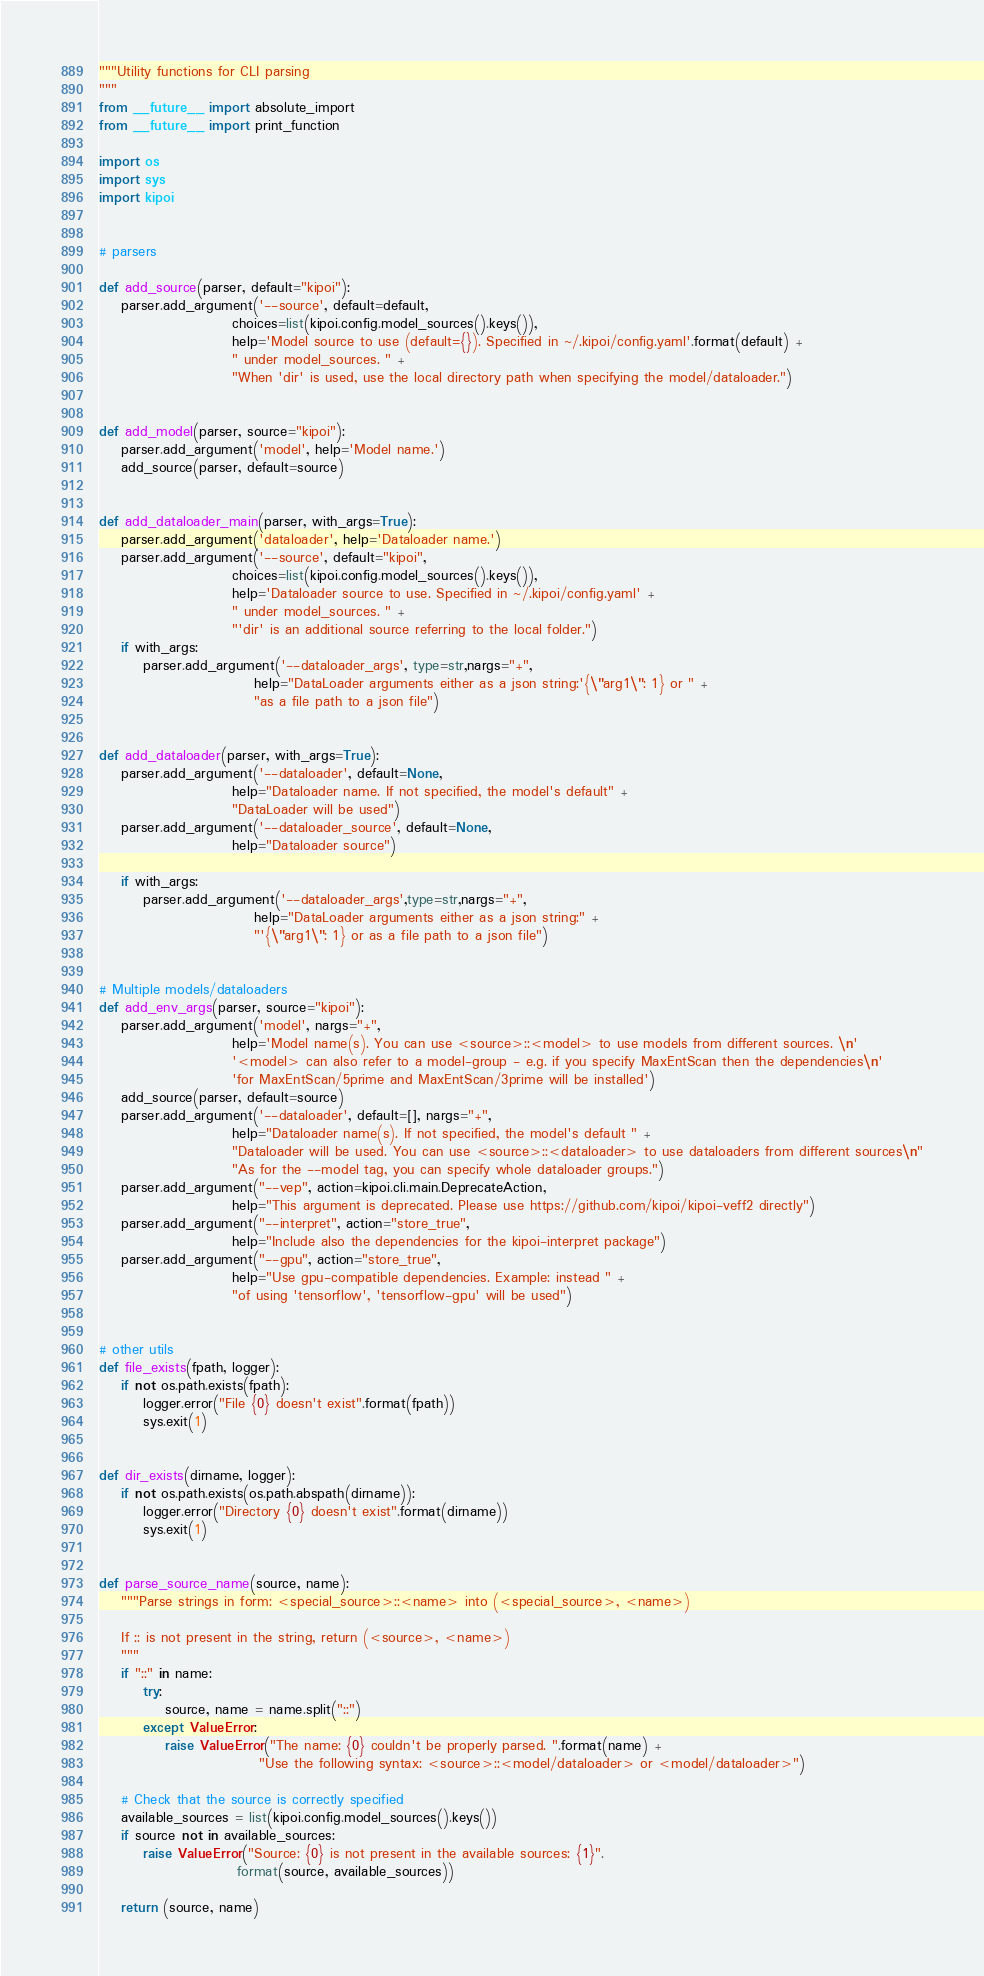<code> <loc_0><loc_0><loc_500><loc_500><_Python_>"""Utility functions for CLI parsing
"""
from __future__ import absolute_import
from __future__ import print_function

import os
import sys
import kipoi


# parsers

def add_source(parser, default="kipoi"):
    parser.add_argument('--source', default=default,
                        choices=list(kipoi.config.model_sources().keys()),
                        help='Model source to use (default={}). Specified in ~/.kipoi/config.yaml'.format(default) +
                        " under model_sources. " +
                        "When 'dir' is used, use the local directory path when specifying the model/dataloader.")


def add_model(parser, source="kipoi"):
    parser.add_argument('model', help='Model name.')
    add_source(parser, default=source)


def add_dataloader_main(parser, with_args=True):
    parser.add_argument('dataloader', help='Dataloader name.')
    parser.add_argument('--source', default="kipoi",
                        choices=list(kipoi.config.model_sources().keys()),
                        help='Dataloader source to use. Specified in ~/.kipoi/config.yaml' +
                        " under model_sources. " +
                        "'dir' is an additional source referring to the local folder.")
    if with_args:
        parser.add_argument('--dataloader_args', type=str,nargs="+",
                            help="DataLoader arguments either as a json string:'{\"arg1\": 1} or " +
                            "as a file path to a json file")


def add_dataloader(parser, with_args=True):
    parser.add_argument('--dataloader', default=None,
                        help="Dataloader name. If not specified, the model's default" +
                        "DataLoader will be used")
    parser.add_argument('--dataloader_source', default=None,
                        help="Dataloader source")

    if with_args:
        parser.add_argument('--dataloader_args',type=str,nargs="+",
                            help="DataLoader arguments either as a json string:" +
                            "'{\"arg1\": 1} or as a file path to a json file")


# Multiple models/dataloaders
def add_env_args(parser, source="kipoi"):
    parser.add_argument('model', nargs="+",
                        help='Model name(s). You can use <source>::<model> to use models from different sources. \n'
                        '<model> can also refer to a model-group - e.g. if you specify MaxEntScan then the dependencies\n'
                        'for MaxEntScan/5prime and MaxEntScan/3prime will be installed')
    add_source(parser, default=source)
    parser.add_argument('--dataloader', default=[], nargs="+",
                        help="Dataloader name(s). If not specified, the model's default " +
                        "Dataloader will be used. You can use <source>::<dataloader> to use dataloaders from different sources\n"
                        "As for the --model tag, you can specify whole dataloader groups.")
    parser.add_argument("--vep", action=kipoi.cli.main.DeprecateAction,
                        help="This argument is deprecated. Please use https://github.com/kipoi/kipoi-veff2 directly")
    parser.add_argument("--interpret", action="store_true",
                        help="Include also the dependencies for the kipoi-interpret package")
    parser.add_argument("--gpu", action="store_true",
                        help="Use gpu-compatible dependencies. Example: instead " +
                        "of using 'tensorflow', 'tensorflow-gpu' will be used")


# other utils
def file_exists(fpath, logger):
    if not os.path.exists(fpath):
        logger.error("File {0} doesn't exist".format(fpath))
        sys.exit(1)


def dir_exists(dirname, logger):
    if not os.path.exists(os.path.abspath(dirname)):
        logger.error("Directory {0} doesn't exist".format(dirname))
        sys.exit(1)


def parse_source_name(source, name):
    """Parse strings in form: <special_source>::<name> into (<special_source>, <name>)

    If :: is not present in the string, return (<source>, <name>)
    """
    if "::" in name:
        try:
            source, name = name.split("::")
        except ValueError:
            raise ValueError("The name: {0} couldn't be properly parsed. ".format(name) +
                             "Use the following syntax: <source>::<model/dataloader> or <model/dataloader>")

    # Check that the source is correctly specified
    available_sources = list(kipoi.config.model_sources().keys())
    if source not in available_sources:
        raise ValueError("Source: {0} is not present in the available sources: {1}".
                         format(source, available_sources))

    return (source, name)
</code> 